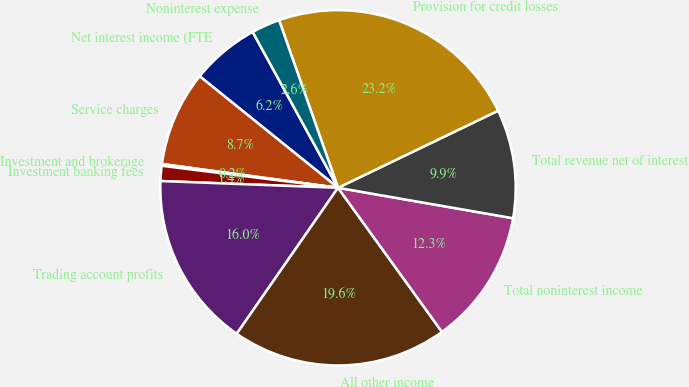Convert chart. <chart><loc_0><loc_0><loc_500><loc_500><pie_chart><fcel>Net interest income (FTE<fcel>Service charges<fcel>Investment and brokerage<fcel>Investment banking fees<fcel>Trading account profits<fcel>All other income<fcel>Total noninterest income<fcel>Total revenue net of interest<fcel>Provision for credit losses<fcel>Noninterest expense<nl><fcel>6.23%<fcel>8.66%<fcel>0.16%<fcel>1.37%<fcel>15.95%<fcel>19.6%<fcel>12.31%<fcel>9.88%<fcel>23.24%<fcel>2.59%<nl></chart> 